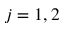<formula> <loc_0><loc_0><loc_500><loc_500>j = 1 , 2</formula> 